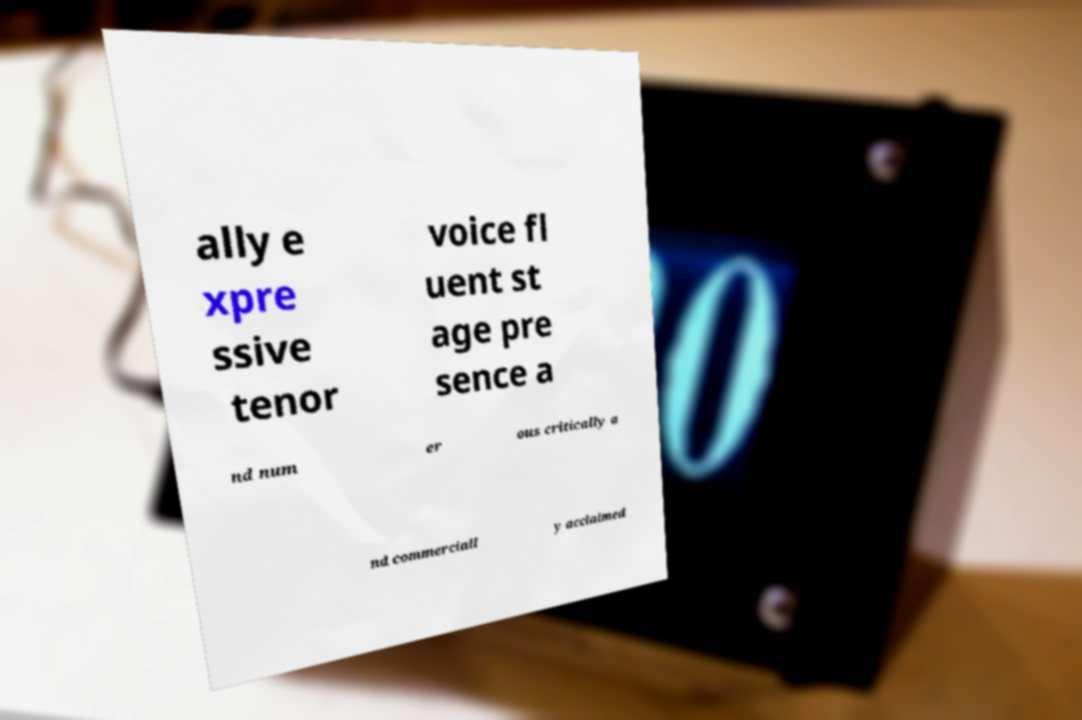Please read and relay the text visible in this image. What does it say? ally e xpre ssive tenor voice fl uent st age pre sence a nd num er ous critically a nd commerciall y acclaimed 